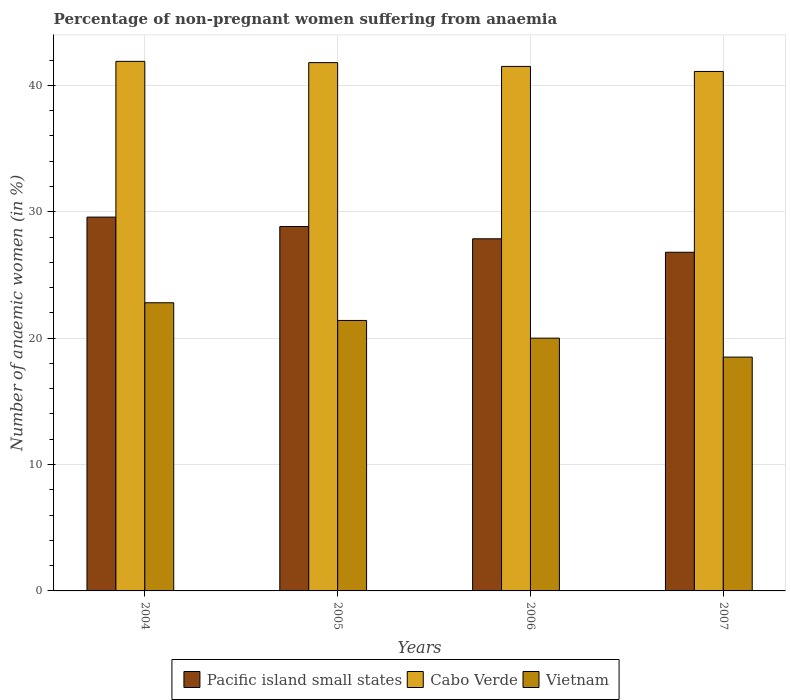Are the number of bars per tick equal to the number of legend labels?
Provide a succinct answer. Yes. How many bars are there on the 2nd tick from the left?
Make the answer very short. 3. How many bars are there on the 1st tick from the right?
Provide a succinct answer. 3. What is the label of the 3rd group of bars from the left?
Provide a short and direct response. 2006. In how many cases, is the number of bars for a given year not equal to the number of legend labels?
Provide a succinct answer. 0. What is the percentage of non-pregnant women suffering from anaemia in Cabo Verde in 2005?
Provide a succinct answer. 41.8. Across all years, what is the maximum percentage of non-pregnant women suffering from anaemia in Vietnam?
Provide a short and direct response. 22.8. Across all years, what is the minimum percentage of non-pregnant women suffering from anaemia in Cabo Verde?
Offer a very short reply. 41.1. In which year was the percentage of non-pregnant women suffering from anaemia in Vietnam maximum?
Make the answer very short. 2004. In which year was the percentage of non-pregnant women suffering from anaemia in Pacific island small states minimum?
Provide a succinct answer. 2007. What is the total percentage of non-pregnant women suffering from anaemia in Pacific island small states in the graph?
Provide a short and direct response. 113.07. What is the difference between the percentage of non-pregnant women suffering from anaemia in Cabo Verde in 2004 and that in 2007?
Provide a short and direct response. 0.8. What is the difference between the percentage of non-pregnant women suffering from anaemia in Cabo Verde in 2007 and the percentage of non-pregnant women suffering from anaemia in Pacific island small states in 2005?
Keep it short and to the point. 12.27. What is the average percentage of non-pregnant women suffering from anaemia in Cabo Verde per year?
Ensure brevity in your answer.  41.57. In the year 2005, what is the difference between the percentage of non-pregnant women suffering from anaemia in Pacific island small states and percentage of non-pregnant women suffering from anaemia in Vietnam?
Keep it short and to the point. 7.43. In how many years, is the percentage of non-pregnant women suffering from anaemia in Pacific island small states greater than 28 %?
Give a very brief answer. 2. What is the ratio of the percentage of non-pregnant women suffering from anaemia in Pacific island small states in 2004 to that in 2005?
Provide a short and direct response. 1.03. What is the difference between the highest and the second highest percentage of non-pregnant women suffering from anaemia in Pacific island small states?
Your answer should be compact. 0.74. What is the difference between the highest and the lowest percentage of non-pregnant women suffering from anaemia in Cabo Verde?
Your answer should be compact. 0.8. What does the 1st bar from the left in 2006 represents?
Provide a succinct answer. Pacific island small states. What does the 1st bar from the right in 2004 represents?
Your answer should be very brief. Vietnam. Are all the bars in the graph horizontal?
Keep it short and to the point. No. Does the graph contain any zero values?
Offer a terse response. No. Does the graph contain grids?
Give a very brief answer. Yes. How many legend labels are there?
Provide a succinct answer. 3. What is the title of the graph?
Your answer should be compact. Percentage of non-pregnant women suffering from anaemia. What is the label or title of the Y-axis?
Offer a very short reply. Number of anaemic women (in %). What is the Number of anaemic women (in %) in Pacific island small states in 2004?
Give a very brief answer. 29.58. What is the Number of anaemic women (in %) in Cabo Verde in 2004?
Provide a succinct answer. 41.9. What is the Number of anaemic women (in %) of Vietnam in 2004?
Ensure brevity in your answer.  22.8. What is the Number of anaemic women (in %) of Pacific island small states in 2005?
Provide a short and direct response. 28.83. What is the Number of anaemic women (in %) in Cabo Verde in 2005?
Ensure brevity in your answer.  41.8. What is the Number of anaemic women (in %) of Vietnam in 2005?
Keep it short and to the point. 21.4. What is the Number of anaemic women (in %) of Pacific island small states in 2006?
Ensure brevity in your answer.  27.86. What is the Number of anaemic women (in %) of Cabo Verde in 2006?
Keep it short and to the point. 41.5. What is the Number of anaemic women (in %) of Pacific island small states in 2007?
Ensure brevity in your answer.  26.8. What is the Number of anaemic women (in %) in Cabo Verde in 2007?
Make the answer very short. 41.1. What is the Number of anaemic women (in %) in Vietnam in 2007?
Your answer should be compact. 18.5. Across all years, what is the maximum Number of anaemic women (in %) in Pacific island small states?
Your response must be concise. 29.58. Across all years, what is the maximum Number of anaemic women (in %) of Cabo Verde?
Your response must be concise. 41.9. Across all years, what is the maximum Number of anaemic women (in %) in Vietnam?
Keep it short and to the point. 22.8. Across all years, what is the minimum Number of anaemic women (in %) in Pacific island small states?
Make the answer very short. 26.8. Across all years, what is the minimum Number of anaemic women (in %) in Cabo Verde?
Offer a very short reply. 41.1. What is the total Number of anaemic women (in %) of Pacific island small states in the graph?
Your answer should be compact. 113.07. What is the total Number of anaemic women (in %) in Cabo Verde in the graph?
Make the answer very short. 166.3. What is the total Number of anaemic women (in %) of Vietnam in the graph?
Provide a succinct answer. 82.7. What is the difference between the Number of anaemic women (in %) of Pacific island small states in 2004 and that in 2005?
Ensure brevity in your answer.  0.74. What is the difference between the Number of anaemic women (in %) in Cabo Verde in 2004 and that in 2005?
Ensure brevity in your answer.  0.1. What is the difference between the Number of anaemic women (in %) of Vietnam in 2004 and that in 2005?
Ensure brevity in your answer.  1.4. What is the difference between the Number of anaemic women (in %) of Pacific island small states in 2004 and that in 2006?
Offer a very short reply. 1.72. What is the difference between the Number of anaemic women (in %) of Cabo Verde in 2004 and that in 2006?
Keep it short and to the point. 0.4. What is the difference between the Number of anaemic women (in %) of Pacific island small states in 2004 and that in 2007?
Provide a short and direct response. 2.78. What is the difference between the Number of anaemic women (in %) of Cabo Verde in 2004 and that in 2007?
Ensure brevity in your answer.  0.8. What is the difference between the Number of anaemic women (in %) of Vietnam in 2004 and that in 2007?
Make the answer very short. 4.3. What is the difference between the Number of anaemic women (in %) in Pacific island small states in 2005 and that in 2006?
Offer a terse response. 0.97. What is the difference between the Number of anaemic women (in %) in Cabo Verde in 2005 and that in 2006?
Offer a very short reply. 0.3. What is the difference between the Number of anaemic women (in %) of Vietnam in 2005 and that in 2006?
Offer a terse response. 1.4. What is the difference between the Number of anaemic women (in %) of Pacific island small states in 2005 and that in 2007?
Your answer should be very brief. 2.04. What is the difference between the Number of anaemic women (in %) in Cabo Verde in 2005 and that in 2007?
Offer a terse response. 0.7. What is the difference between the Number of anaemic women (in %) in Pacific island small states in 2006 and that in 2007?
Provide a short and direct response. 1.07. What is the difference between the Number of anaemic women (in %) in Pacific island small states in 2004 and the Number of anaemic women (in %) in Cabo Verde in 2005?
Provide a succinct answer. -12.22. What is the difference between the Number of anaemic women (in %) of Pacific island small states in 2004 and the Number of anaemic women (in %) of Vietnam in 2005?
Offer a very short reply. 8.18. What is the difference between the Number of anaemic women (in %) in Cabo Verde in 2004 and the Number of anaemic women (in %) in Vietnam in 2005?
Your answer should be very brief. 20.5. What is the difference between the Number of anaemic women (in %) of Pacific island small states in 2004 and the Number of anaemic women (in %) of Cabo Verde in 2006?
Ensure brevity in your answer.  -11.92. What is the difference between the Number of anaemic women (in %) in Pacific island small states in 2004 and the Number of anaemic women (in %) in Vietnam in 2006?
Ensure brevity in your answer.  9.58. What is the difference between the Number of anaemic women (in %) in Cabo Verde in 2004 and the Number of anaemic women (in %) in Vietnam in 2006?
Provide a short and direct response. 21.9. What is the difference between the Number of anaemic women (in %) of Pacific island small states in 2004 and the Number of anaemic women (in %) of Cabo Verde in 2007?
Keep it short and to the point. -11.52. What is the difference between the Number of anaemic women (in %) in Pacific island small states in 2004 and the Number of anaemic women (in %) in Vietnam in 2007?
Your answer should be compact. 11.08. What is the difference between the Number of anaemic women (in %) of Cabo Verde in 2004 and the Number of anaemic women (in %) of Vietnam in 2007?
Offer a terse response. 23.4. What is the difference between the Number of anaemic women (in %) in Pacific island small states in 2005 and the Number of anaemic women (in %) in Cabo Verde in 2006?
Ensure brevity in your answer.  -12.67. What is the difference between the Number of anaemic women (in %) of Pacific island small states in 2005 and the Number of anaemic women (in %) of Vietnam in 2006?
Give a very brief answer. 8.83. What is the difference between the Number of anaemic women (in %) in Cabo Verde in 2005 and the Number of anaemic women (in %) in Vietnam in 2006?
Ensure brevity in your answer.  21.8. What is the difference between the Number of anaemic women (in %) of Pacific island small states in 2005 and the Number of anaemic women (in %) of Cabo Verde in 2007?
Provide a succinct answer. -12.27. What is the difference between the Number of anaemic women (in %) in Pacific island small states in 2005 and the Number of anaemic women (in %) in Vietnam in 2007?
Ensure brevity in your answer.  10.33. What is the difference between the Number of anaemic women (in %) of Cabo Verde in 2005 and the Number of anaemic women (in %) of Vietnam in 2007?
Offer a very short reply. 23.3. What is the difference between the Number of anaemic women (in %) of Pacific island small states in 2006 and the Number of anaemic women (in %) of Cabo Verde in 2007?
Give a very brief answer. -13.24. What is the difference between the Number of anaemic women (in %) in Pacific island small states in 2006 and the Number of anaemic women (in %) in Vietnam in 2007?
Ensure brevity in your answer.  9.36. What is the average Number of anaemic women (in %) in Pacific island small states per year?
Your answer should be compact. 28.27. What is the average Number of anaemic women (in %) of Cabo Verde per year?
Your answer should be compact. 41.58. What is the average Number of anaemic women (in %) in Vietnam per year?
Your answer should be very brief. 20.68. In the year 2004, what is the difference between the Number of anaemic women (in %) in Pacific island small states and Number of anaemic women (in %) in Cabo Verde?
Your answer should be compact. -12.32. In the year 2004, what is the difference between the Number of anaemic women (in %) in Pacific island small states and Number of anaemic women (in %) in Vietnam?
Your answer should be compact. 6.78. In the year 2004, what is the difference between the Number of anaemic women (in %) of Cabo Verde and Number of anaemic women (in %) of Vietnam?
Your answer should be very brief. 19.1. In the year 2005, what is the difference between the Number of anaemic women (in %) of Pacific island small states and Number of anaemic women (in %) of Cabo Verde?
Offer a terse response. -12.97. In the year 2005, what is the difference between the Number of anaemic women (in %) of Pacific island small states and Number of anaemic women (in %) of Vietnam?
Make the answer very short. 7.43. In the year 2005, what is the difference between the Number of anaemic women (in %) of Cabo Verde and Number of anaemic women (in %) of Vietnam?
Offer a terse response. 20.4. In the year 2006, what is the difference between the Number of anaemic women (in %) in Pacific island small states and Number of anaemic women (in %) in Cabo Verde?
Your answer should be very brief. -13.64. In the year 2006, what is the difference between the Number of anaemic women (in %) in Pacific island small states and Number of anaemic women (in %) in Vietnam?
Your response must be concise. 7.86. In the year 2007, what is the difference between the Number of anaemic women (in %) of Pacific island small states and Number of anaemic women (in %) of Cabo Verde?
Keep it short and to the point. -14.3. In the year 2007, what is the difference between the Number of anaemic women (in %) of Pacific island small states and Number of anaemic women (in %) of Vietnam?
Keep it short and to the point. 8.3. In the year 2007, what is the difference between the Number of anaemic women (in %) in Cabo Verde and Number of anaemic women (in %) in Vietnam?
Make the answer very short. 22.6. What is the ratio of the Number of anaemic women (in %) of Pacific island small states in 2004 to that in 2005?
Ensure brevity in your answer.  1.03. What is the ratio of the Number of anaemic women (in %) of Vietnam in 2004 to that in 2005?
Offer a very short reply. 1.07. What is the ratio of the Number of anaemic women (in %) in Pacific island small states in 2004 to that in 2006?
Offer a very short reply. 1.06. What is the ratio of the Number of anaemic women (in %) of Cabo Verde in 2004 to that in 2006?
Keep it short and to the point. 1.01. What is the ratio of the Number of anaemic women (in %) of Vietnam in 2004 to that in 2006?
Offer a terse response. 1.14. What is the ratio of the Number of anaemic women (in %) of Pacific island small states in 2004 to that in 2007?
Make the answer very short. 1.1. What is the ratio of the Number of anaemic women (in %) of Cabo Verde in 2004 to that in 2007?
Your response must be concise. 1.02. What is the ratio of the Number of anaemic women (in %) in Vietnam in 2004 to that in 2007?
Make the answer very short. 1.23. What is the ratio of the Number of anaemic women (in %) in Pacific island small states in 2005 to that in 2006?
Your answer should be very brief. 1.03. What is the ratio of the Number of anaemic women (in %) in Vietnam in 2005 to that in 2006?
Your answer should be compact. 1.07. What is the ratio of the Number of anaemic women (in %) in Pacific island small states in 2005 to that in 2007?
Your answer should be compact. 1.08. What is the ratio of the Number of anaemic women (in %) in Vietnam in 2005 to that in 2007?
Your answer should be very brief. 1.16. What is the ratio of the Number of anaemic women (in %) of Pacific island small states in 2006 to that in 2007?
Provide a succinct answer. 1.04. What is the ratio of the Number of anaemic women (in %) of Cabo Verde in 2006 to that in 2007?
Keep it short and to the point. 1.01. What is the ratio of the Number of anaemic women (in %) in Vietnam in 2006 to that in 2007?
Your response must be concise. 1.08. What is the difference between the highest and the second highest Number of anaemic women (in %) in Pacific island small states?
Your answer should be compact. 0.74. What is the difference between the highest and the second highest Number of anaemic women (in %) of Cabo Verde?
Provide a short and direct response. 0.1. What is the difference between the highest and the lowest Number of anaemic women (in %) of Pacific island small states?
Your answer should be very brief. 2.78. What is the difference between the highest and the lowest Number of anaemic women (in %) of Cabo Verde?
Your answer should be compact. 0.8. What is the difference between the highest and the lowest Number of anaemic women (in %) in Vietnam?
Your answer should be compact. 4.3. 